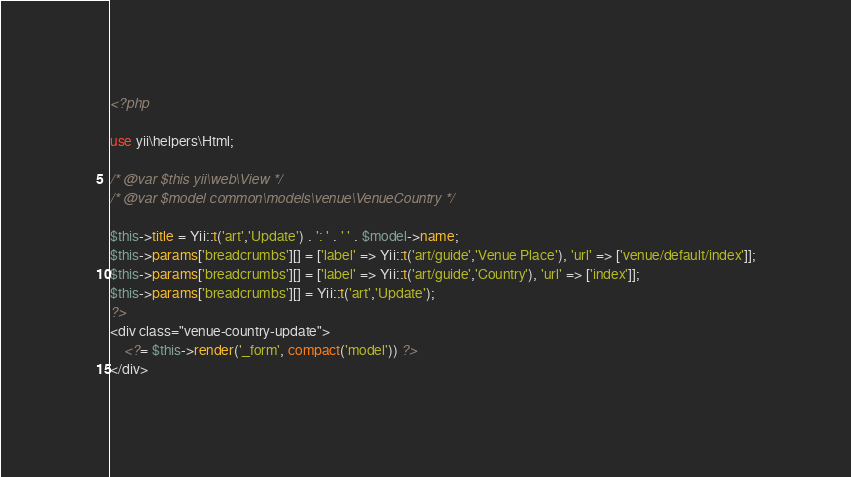Convert code to text. <code><loc_0><loc_0><loc_500><loc_500><_PHP_><?php

use yii\helpers\Html;

/* @var $this yii\web\View */
/* @var $model common\models\venue\VenueCountry */

$this->title = Yii::t('art','Update') . ': ' . ' ' . $model->name;
$this->params['breadcrumbs'][] = ['label' => Yii::t('art/guide','Venue Place'), 'url' => ['venue/default/index']];
$this->params['breadcrumbs'][] = ['label' => Yii::t('art/guide','Country'), 'url' => ['index']];
$this->params['breadcrumbs'][] = Yii::t('art','Update');
?>
<div class="venue-country-update">
    <?= $this->render('_form', compact('model')) ?>
</div></code> 